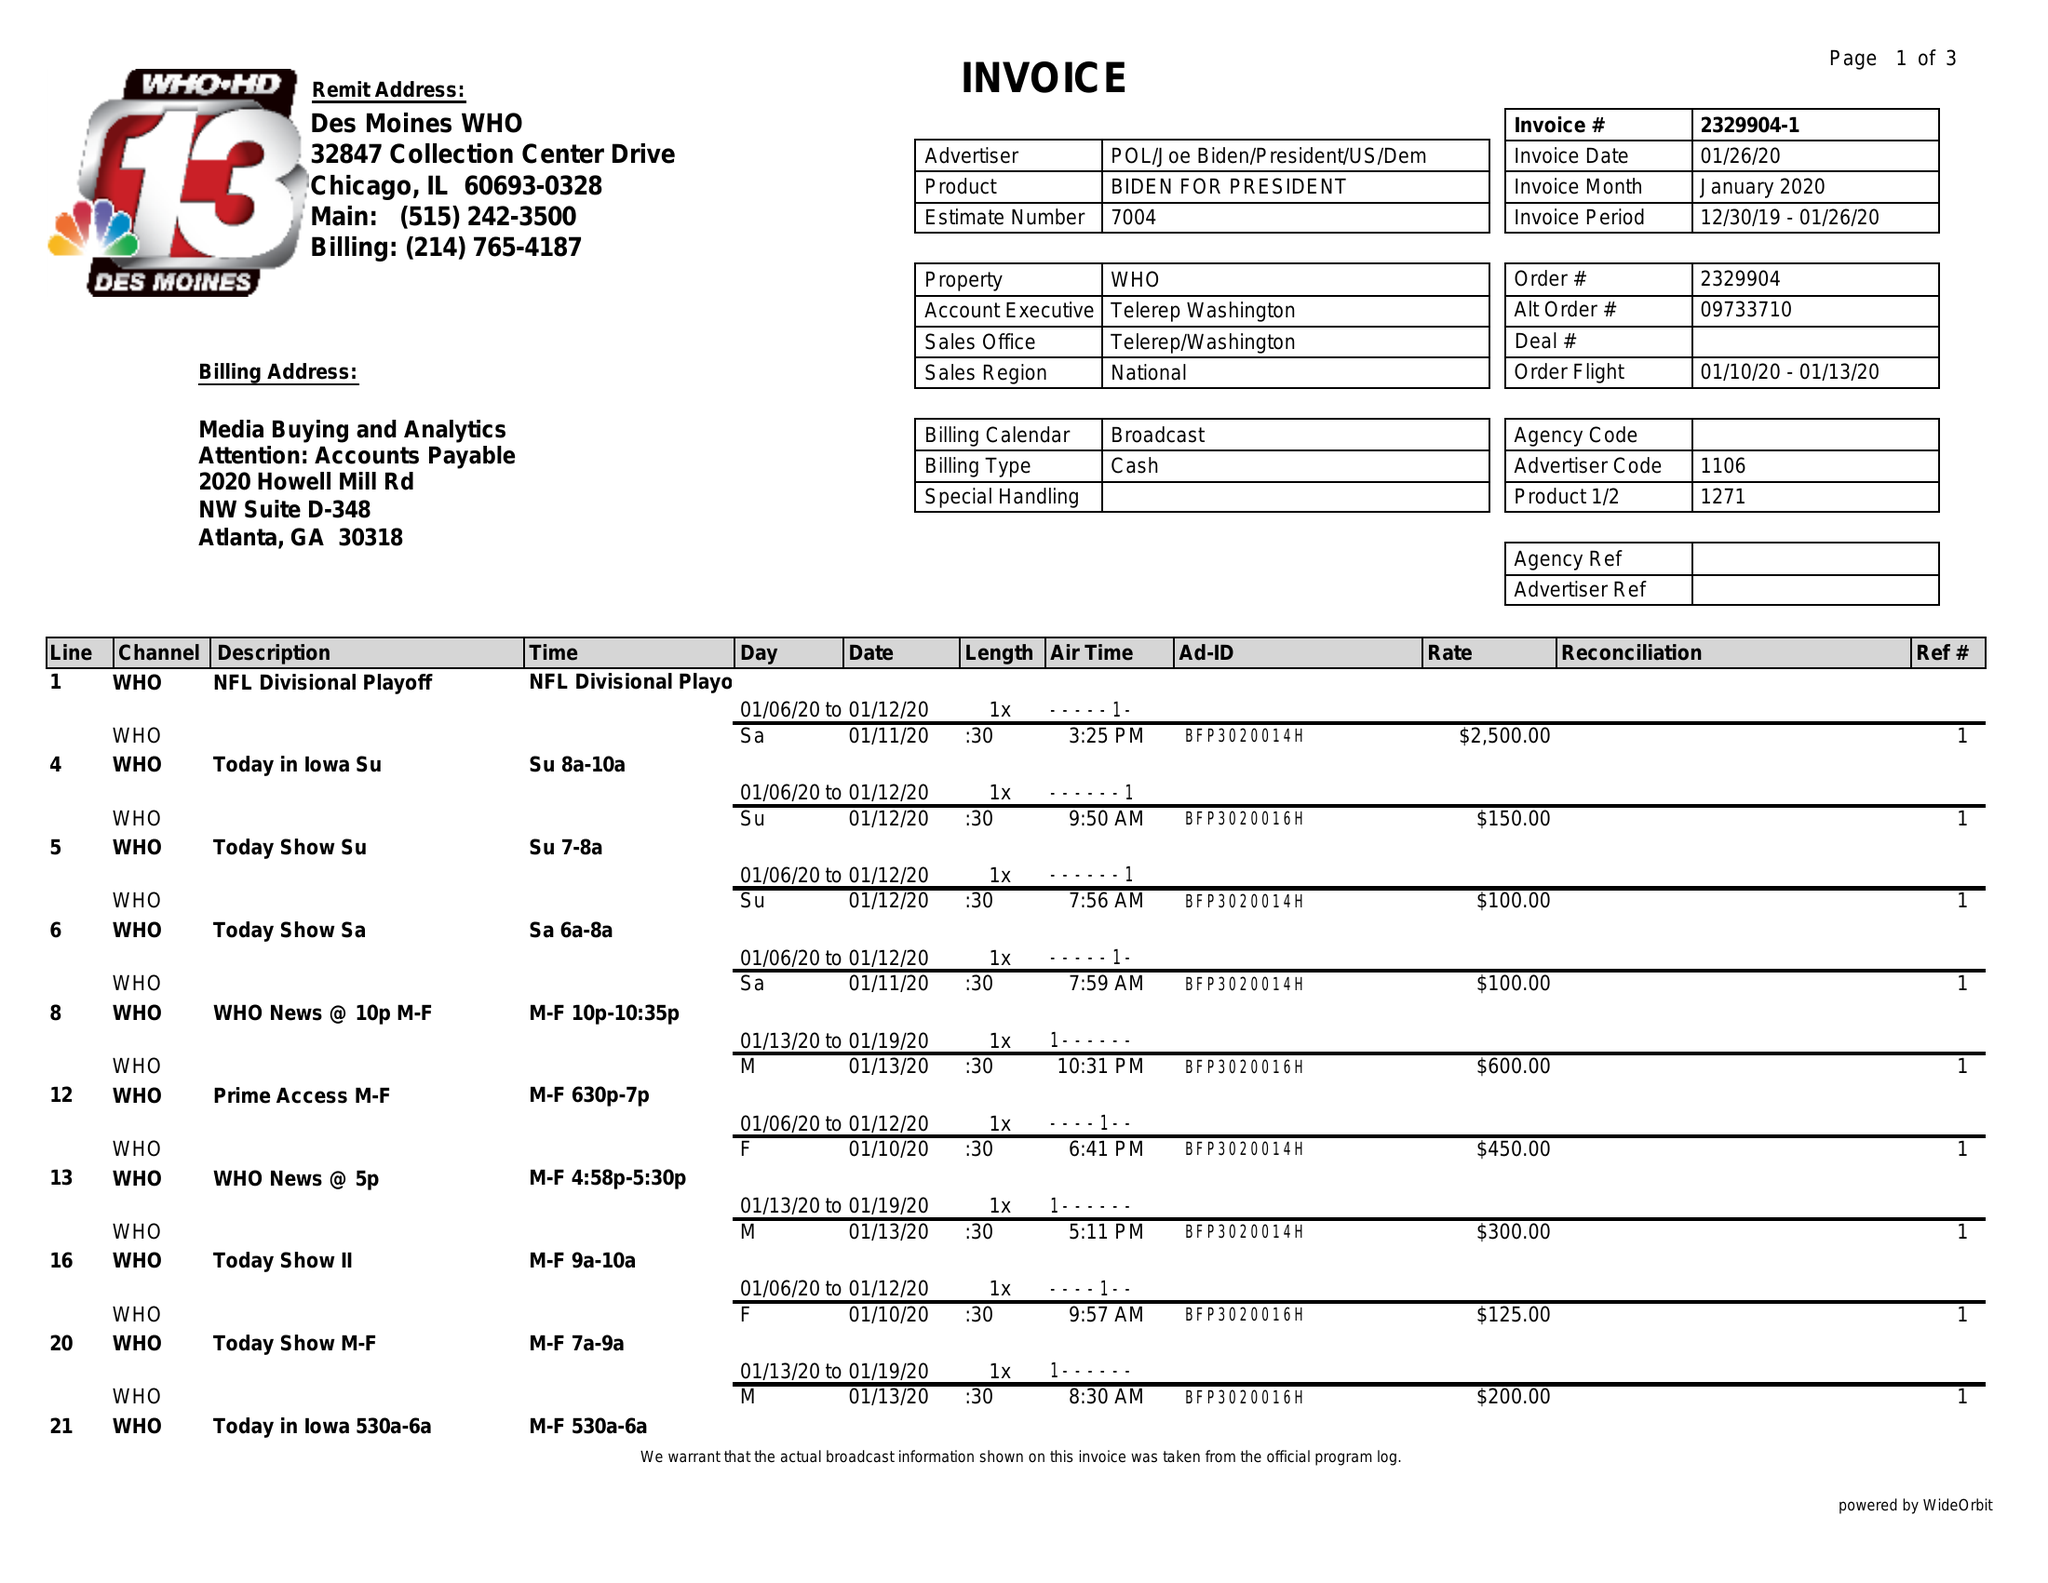What is the value for the advertiser?
Answer the question using a single word or phrase. POL/JOEBIDEN/PRESIDENT/US/DEM 